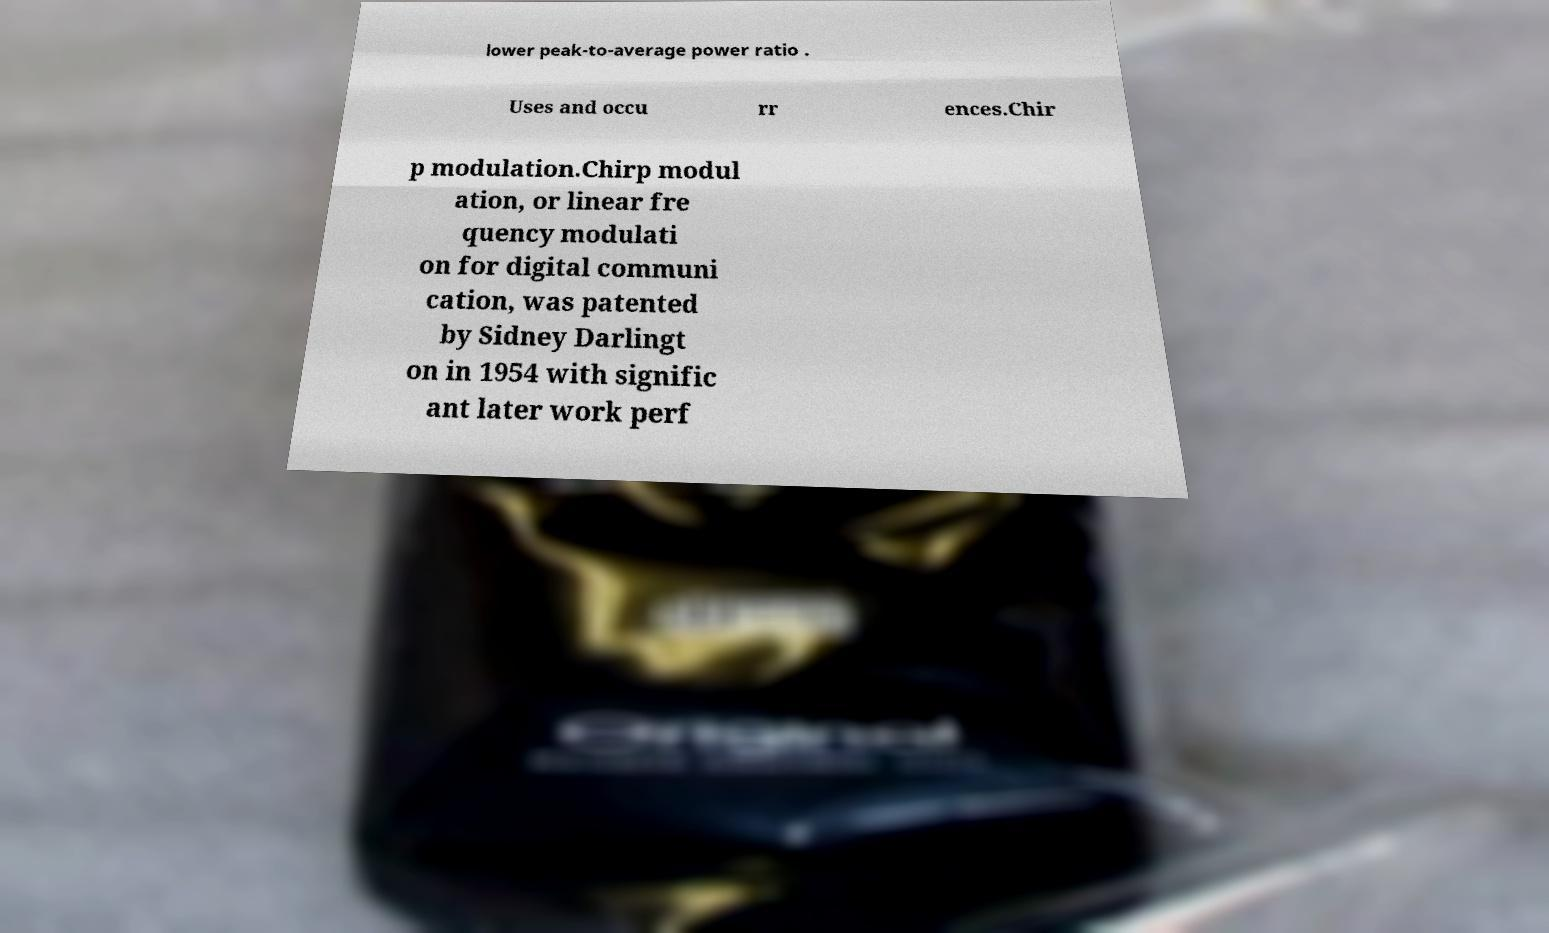I need the written content from this picture converted into text. Can you do that? lower peak-to-average power ratio . Uses and occu rr ences.Chir p modulation.Chirp modul ation, or linear fre quency modulati on for digital communi cation, was patented by Sidney Darlingt on in 1954 with signific ant later work perf 